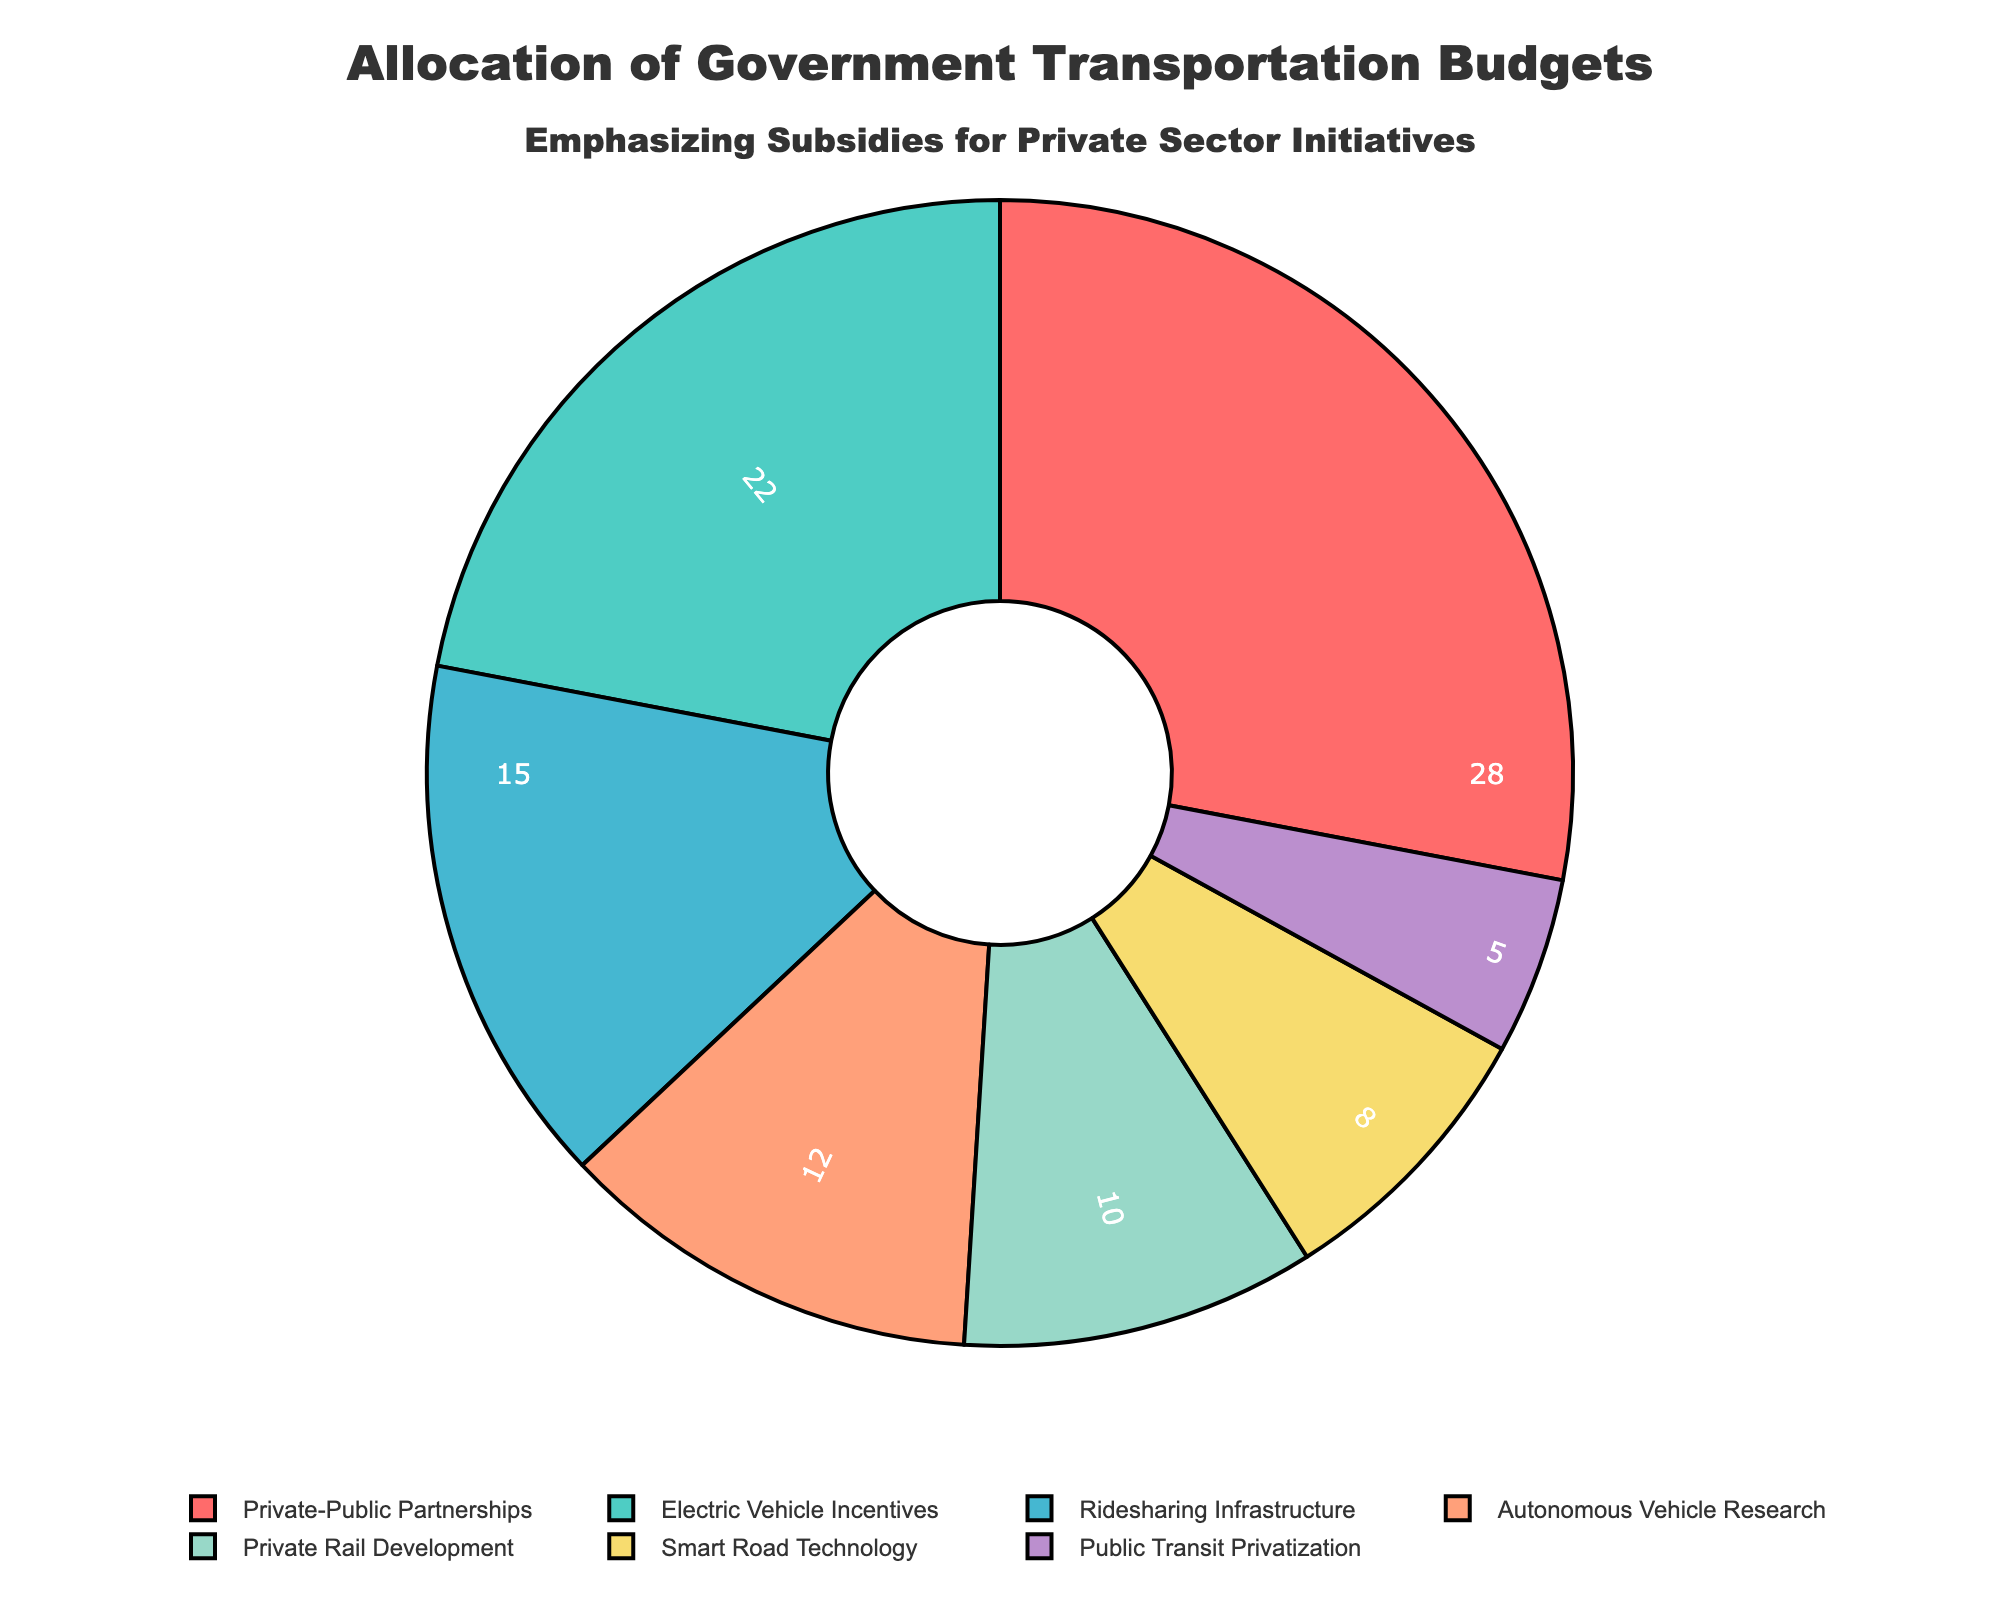What's the largest category in the pie chart? The largest category is indicated by the biggest slice of the pie chart. From the chart, the biggest slice belongs to "Private-Public Partnerships" with 28%.
Answer: Private-Public Partnerships What's the total percentage allocated to research and new technologies (Autonomous Vehicle Research + Smart Road Technology)? Add the percentages of Autonomous Vehicle Research (12%) and Smart Road Technology (8%). 12% + 8% = 20%
Answer: 20% Which category has the smallest slice in the pie chart? The smallest slice corresponds to the category with the lowest percentage. In this case, it is "Public Transit Privatization" with 5%.
Answer: Public Transit Privatization Compare the budget allocation between Electric Vehicle Incentives and Private Rail Development. Which one gets more funding? Electric Vehicle Incentives receive 22% of the budget, while Private Rail Development receives 10%. Therefore, Electric Vehicle Incentives get more funding.
Answer: Electric Vehicle Incentives What is the combined budget percentage for the categories allocated to ridesharing and public transit privatization? Add the percentages of Ridesharing Infrastructure (15%) and Public Transit Privatization (5%). 15% + 5% = 20%
Answer: 20% How much more budget percentage is allocated to Private-Public Partnerships than to Smart Road Technology? Subtract the percentage of Smart Road Technology (8%) from Private-Public Partnerships (28%). 28% - 8% = 20%
Answer: 20% What percentage of the budget is focused on initiatives supporting electric and autonomous vehicles? Add the percentages of Electric Vehicle Incentives (22%) and Autonomous Vehicle Research (12%). 22% + 12% = 34%
Answer: 34% Which category receives approximately twice the funding than Public Transit Privatization? Compare the percentages: Public Transit Privatization gets 5%, and Smart Road Technology gets 8%. Since 10% is approximately double of 5%, the closest category is Private Rail Development with 10%.
Answer: Private Rail Development 